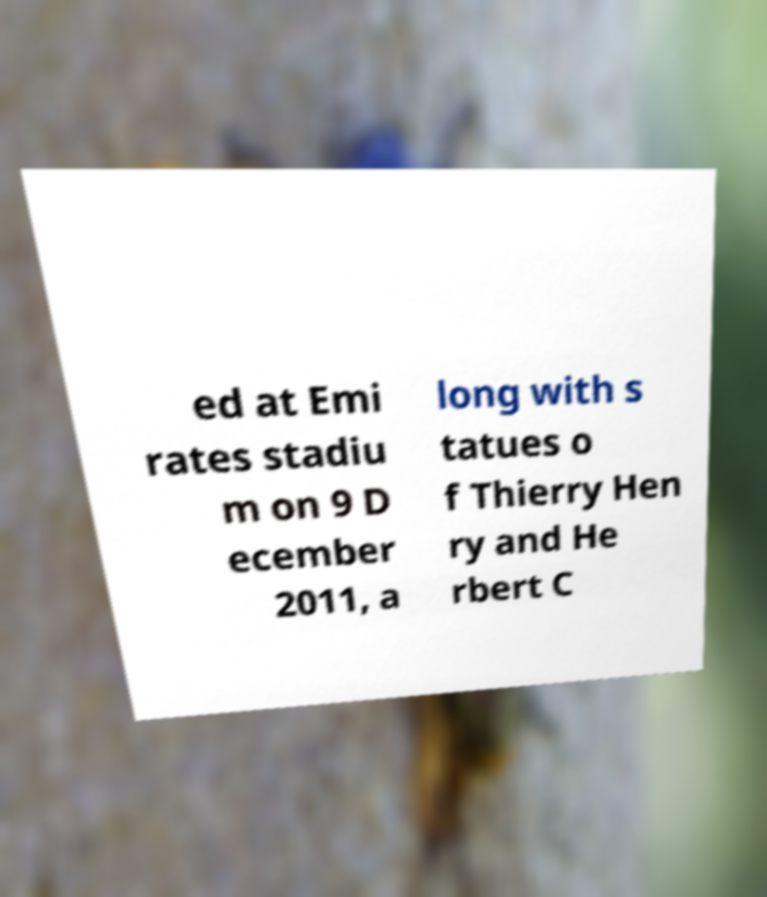Please read and relay the text visible in this image. What does it say? ed at Emi rates stadiu m on 9 D ecember 2011, a long with s tatues o f Thierry Hen ry and He rbert C 